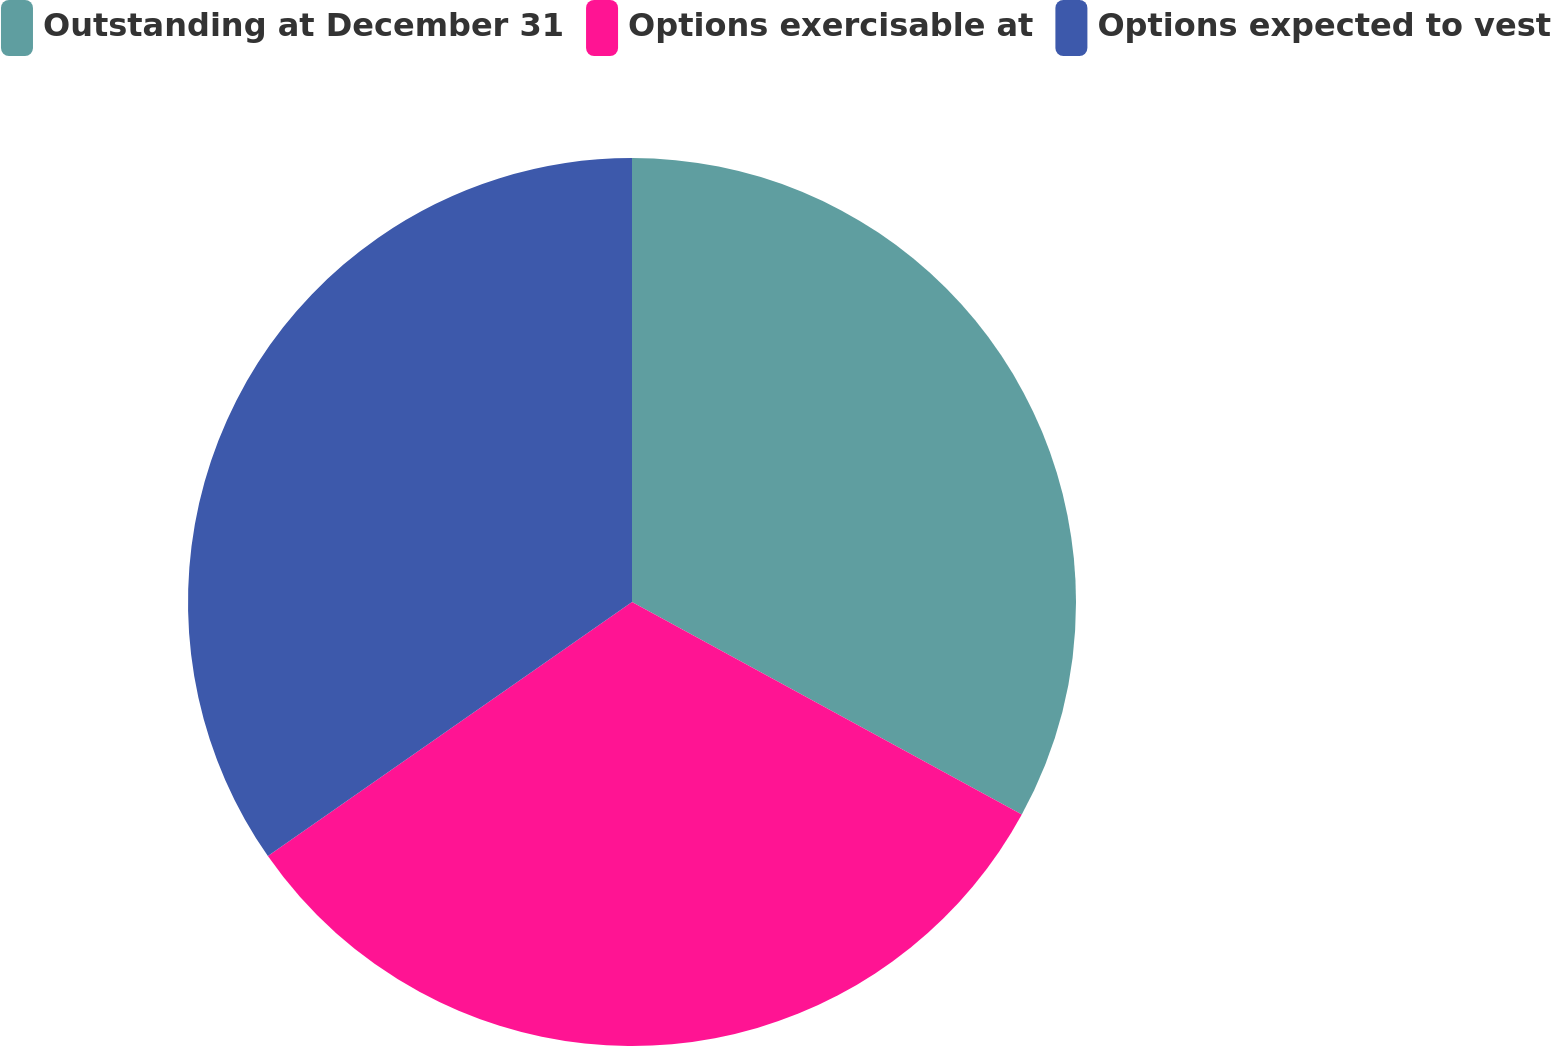<chart> <loc_0><loc_0><loc_500><loc_500><pie_chart><fcel>Outstanding at December 31<fcel>Options exercisable at<fcel>Options expected to vest<nl><fcel>32.95%<fcel>32.36%<fcel>34.7%<nl></chart> 